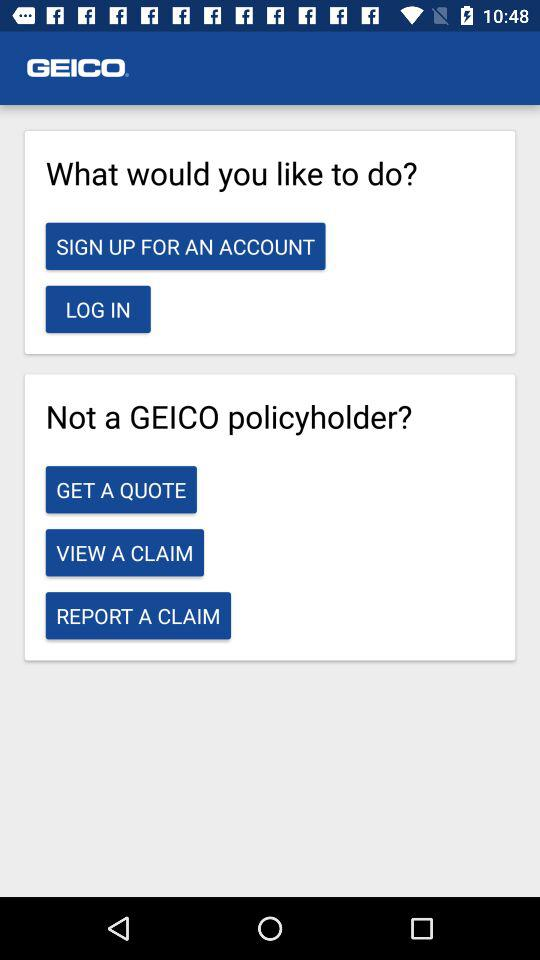What is the application name? The application name is "GEICO". 